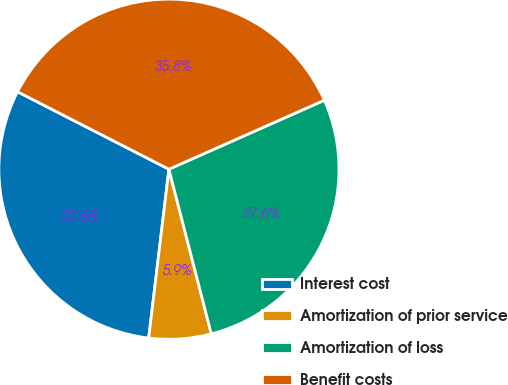Convert chart to OTSL. <chart><loc_0><loc_0><loc_500><loc_500><pie_chart><fcel>Interest cost<fcel>Amortization of prior service<fcel>Amortization of loss<fcel>Benefit costs<nl><fcel>30.63%<fcel>5.91%<fcel>27.64%<fcel>35.83%<nl></chart> 